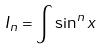<formula> <loc_0><loc_0><loc_500><loc_500>I _ { n } = \int \sin ^ { n } x</formula> 